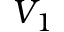<formula> <loc_0><loc_0><loc_500><loc_500>V _ { 1 }</formula> 